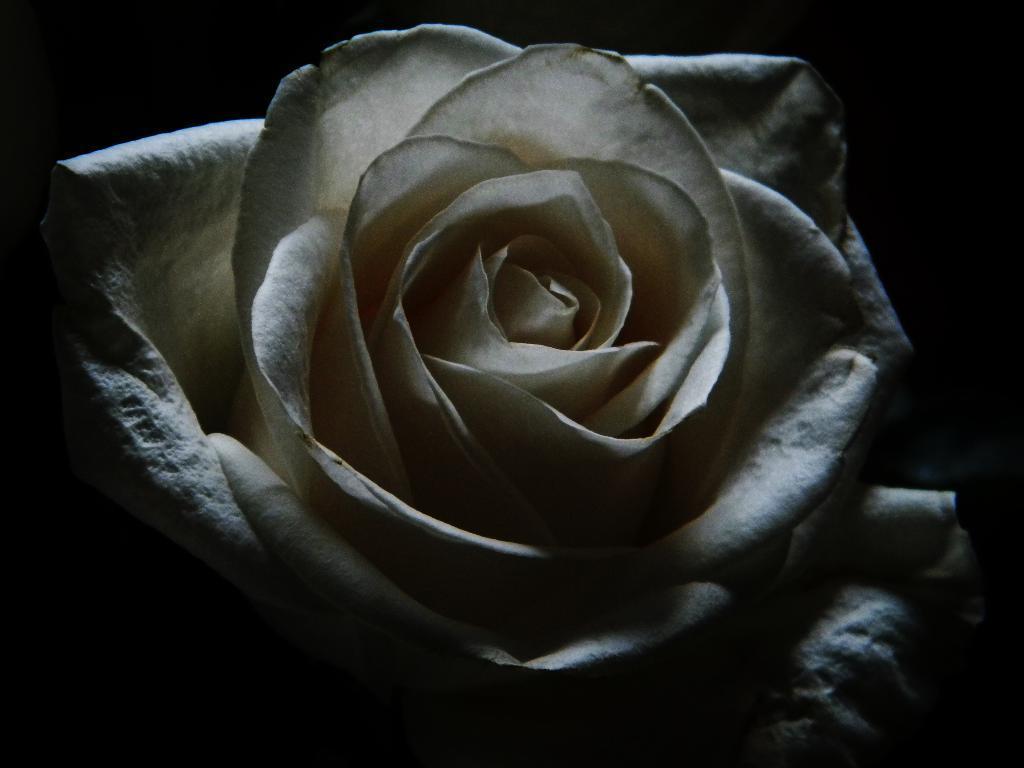Describe this image in one or two sentences. In this image there is a white rose, in the background it is dark. 